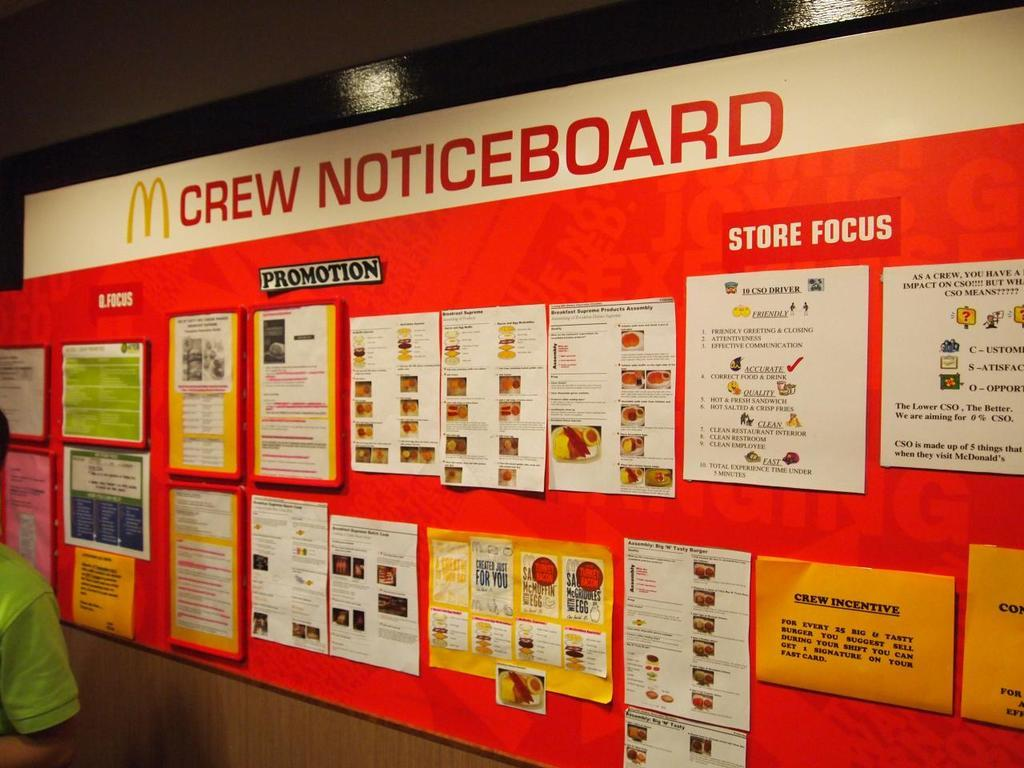<image>
Write a terse but informative summary of the picture. Red board with many different papers and the words "Crew Noticeboard" on top. 